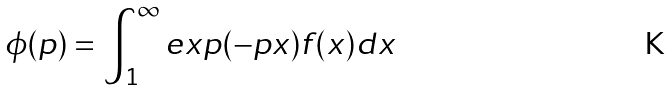<formula> <loc_0><loc_0><loc_500><loc_500>\phi ( p ) = \int _ { 1 } ^ { \infty } e x p ( - p x ) f ( x ) d x</formula> 